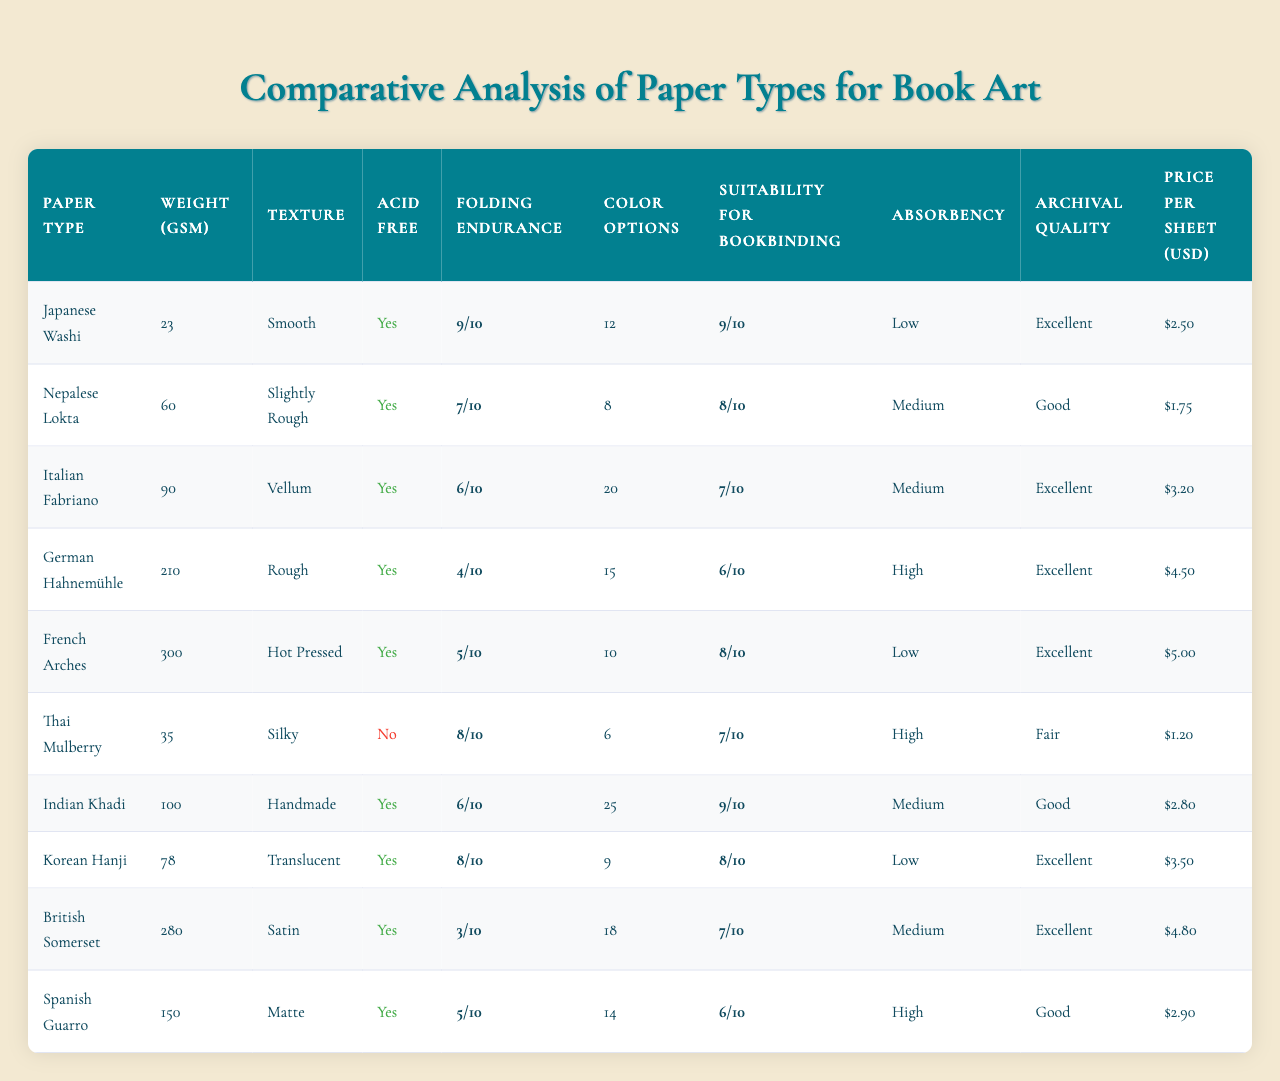What is the weight in GSM of French Arches paper? The table lists French Arches under the Paper Type column, and its corresponding Weight GSM value is found in the same row. The value is 300 GSM.
Answer: 300 Which paper type has the highest folding endurance? By looking at the Folding Endurance values, we can see that Japanese Washi has the highest value of 9.
Answer: Japanese Washi Is Thai Mulberry paper acid-free? The Acid Free column indicates whether each paper type is acid-free or not. Thai Mulberry has a 'No' next to it, indicating it is not acid-free.
Answer: No What is the average price per sheet of the papers listed? To find the average, we add all the prices: (2.50 + 1.75 + 3.20 + 4.50 + 5.00 + 1.20 + 2.80 + 3.50 + 4.80 + 2.90) = 28.65. Then divide by the number of papers (10), resulting in an average price of 2.865.
Answer: 2.87 How many paper types have a weight greater than 100 GSM? By examining the Weight GSM column, we identify which paper types exceed 100 GSM. These are Italian Fabriano (90) and higher. The papers meeting this criterion are German Hahnemühle (210), French Arches (300), British Somerset (280), and Spanish Guarro (150), totaling four types.
Answer: 4 What is the color option count for Korean Hanji paper? The Color Options row corresponding to Korean Hanji paper indicates the value listed is 9.
Answer: 9 Which paper has the best archival quality? We check the Archival Quality column to find "Excellent," which is noted for various papers: Japanese Washi, Italian Fabriano, German Hahnemühle, French Arches, Korean Hanji, and British Somerset. Among these, the first one listed is Japanese Washi, indicating it as one of the best in this category.
Answer: Japanese Washi Is the absorbency of German Hahnemühle paper high? The Absorbency column shows "High" next to German Hahnemühle, confirming its high absorbency.
Answer: Yes What is the difference in price between Spanish Guarro and Thai Mulberry? To find the price difference, we subtract the price of Thai Mulberry (1.20) from Spanish Guarro (4.80): 4.80 - 1.20 = 3.60.
Answer: 3.60 How many papers are suitable for bookbinding (rating of 8 or higher)? Looking at the Suitability for Bookbinding column, we can identify papers rated 8 or higher: Japanese Washi (9), Nepalese Lokta (8), Indian Khadi (9), Korean Hanji (8), and French Arches (8). This totals five paper types suitable for bookbinding.
Answer: 5 